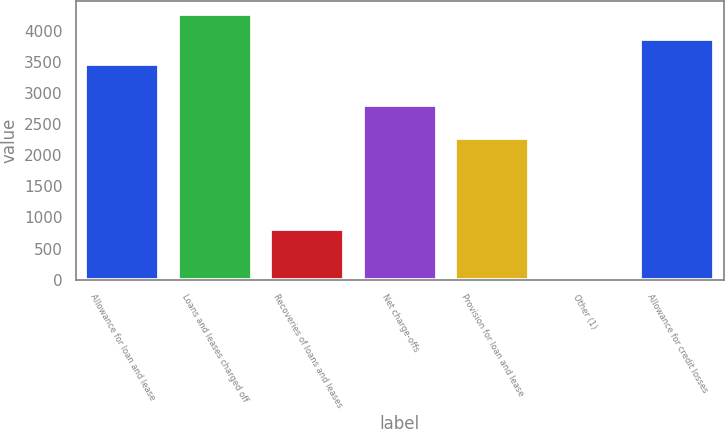Convert chart. <chart><loc_0><loc_0><loc_500><loc_500><bar_chart><fcel>Allowance for loan and lease<fcel>Loans and leases charged off<fcel>Recoveries of loans and leases<fcel>Net charge-offs<fcel>Provision for loan and lease<fcel>Other (1)<fcel>Allowance for credit losses<nl><fcel>3471<fcel>4271<fcel>813<fcel>2807<fcel>2278<fcel>47<fcel>3871<nl></chart> 